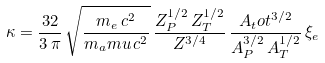<formula> <loc_0><loc_0><loc_500><loc_500>\kappa = \frac { 3 2 } { 3 \, \pi } \, \sqrt { \frac { m _ { e } \, c ^ { 2 } } { m _ { a } m u \, c ^ { 2 } } } \, \frac { Z _ { P } ^ { 1 / 2 } \, Z _ { T } ^ { 1 / 2 } } { Z ^ { 3 / 4 } } \, \frac { A _ { t } o t ^ { 3 / 2 } } { A _ { P } ^ { 3 / 2 } \, A _ { T } ^ { 1 / 2 } } \, \xi _ { e }</formula> 